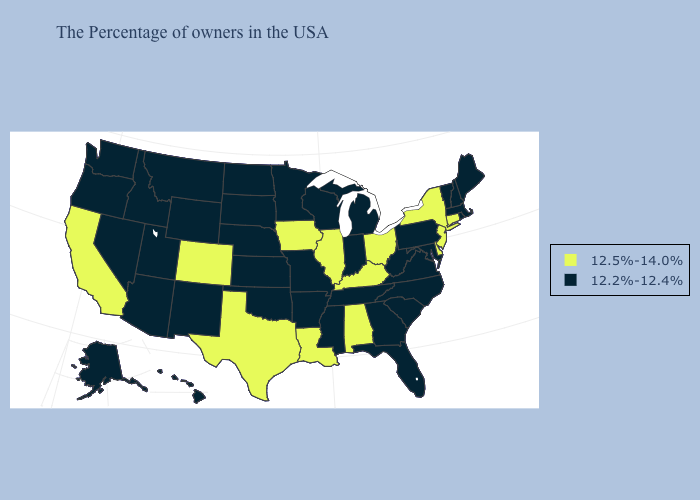What is the value of Texas?
Answer briefly. 12.5%-14.0%. Among the states that border New Jersey , does New York have the highest value?
Short answer required. Yes. Which states hav the highest value in the South?
Quick response, please. Delaware, Kentucky, Alabama, Louisiana, Texas. What is the lowest value in states that border California?
Write a very short answer. 12.2%-12.4%. Does New York have the highest value in the Northeast?
Give a very brief answer. Yes. What is the lowest value in the Northeast?
Give a very brief answer. 12.2%-12.4%. Does the map have missing data?
Quick response, please. No. What is the value of Maryland?
Quick response, please. 12.2%-12.4%. Name the states that have a value in the range 12.5%-14.0%?
Answer briefly. Connecticut, New York, New Jersey, Delaware, Ohio, Kentucky, Alabama, Illinois, Louisiana, Iowa, Texas, Colorado, California. Name the states that have a value in the range 12.2%-12.4%?
Concise answer only. Maine, Massachusetts, Rhode Island, New Hampshire, Vermont, Maryland, Pennsylvania, Virginia, North Carolina, South Carolina, West Virginia, Florida, Georgia, Michigan, Indiana, Tennessee, Wisconsin, Mississippi, Missouri, Arkansas, Minnesota, Kansas, Nebraska, Oklahoma, South Dakota, North Dakota, Wyoming, New Mexico, Utah, Montana, Arizona, Idaho, Nevada, Washington, Oregon, Alaska, Hawaii. Does Alabama have the highest value in the South?
Give a very brief answer. Yes. Which states have the lowest value in the USA?
Keep it brief. Maine, Massachusetts, Rhode Island, New Hampshire, Vermont, Maryland, Pennsylvania, Virginia, North Carolina, South Carolina, West Virginia, Florida, Georgia, Michigan, Indiana, Tennessee, Wisconsin, Mississippi, Missouri, Arkansas, Minnesota, Kansas, Nebraska, Oklahoma, South Dakota, North Dakota, Wyoming, New Mexico, Utah, Montana, Arizona, Idaho, Nevada, Washington, Oregon, Alaska, Hawaii. Among the states that border Florida , does Alabama have the highest value?
Answer briefly. Yes. What is the lowest value in the USA?
Keep it brief. 12.2%-12.4%. Does New Jersey have the lowest value in the Northeast?
Keep it brief. No. 